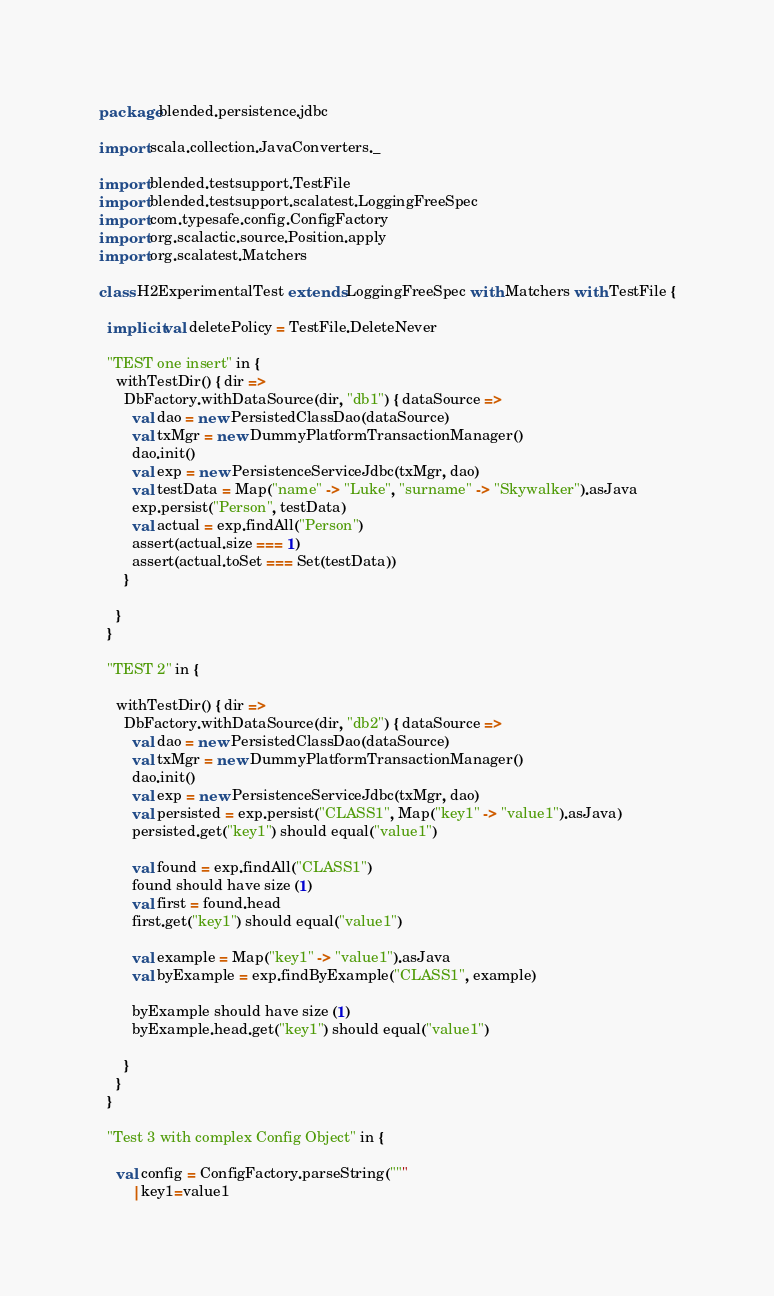Convert code to text. <code><loc_0><loc_0><loc_500><loc_500><_Scala_>package blended.persistence.jdbc

import scala.collection.JavaConverters._

import blended.testsupport.TestFile
import blended.testsupport.scalatest.LoggingFreeSpec
import com.typesafe.config.ConfigFactory
import org.scalactic.source.Position.apply
import org.scalatest.Matchers

class H2ExperimentalTest extends LoggingFreeSpec with Matchers with TestFile {

  implicit val deletePolicy = TestFile.DeleteNever

  "TEST one insert" in {
    withTestDir() { dir =>
      DbFactory.withDataSource(dir, "db1") { dataSource =>
        val dao = new PersistedClassDao(dataSource)
        val txMgr = new DummyPlatformTransactionManager()
        dao.init()
        val exp = new PersistenceServiceJdbc(txMgr, dao)
        val testData = Map("name" -> "Luke", "surname" -> "Skywalker").asJava
        exp.persist("Person", testData)
        val actual = exp.findAll("Person")
        assert(actual.size === 1)
        assert(actual.toSet === Set(testData))
      }

    }
  }

  "TEST 2" in {

    withTestDir() { dir =>
      DbFactory.withDataSource(dir, "db2") { dataSource =>
        val dao = new PersistedClassDao(dataSource)
        val txMgr = new DummyPlatformTransactionManager()
        dao.init()
        val exp = new PersistenceServiceJdbc(txMgr, dao)
        val persisted = exp.persist("CLASS1", Map("key1" -> "value1").asJava)
        persisted.get("key1") should equal("value1")

        val found = exp.findAll("CLASS1")
        found should have size (1)
        val first = found.head
        first.get("key1") should equal("value1")

        val example = Map("key1" -> "value1").asJava
        val byExample = exp.findByExample("CLASS1", example)

        byExample should have size (1)
        byExample.head.get("key1") should equal("value1")

      }
    }
  }

  "Test 3 with complex Config Object" in {

    val config = ConfigFactory.parseString("""
        |key1=value1</code> 